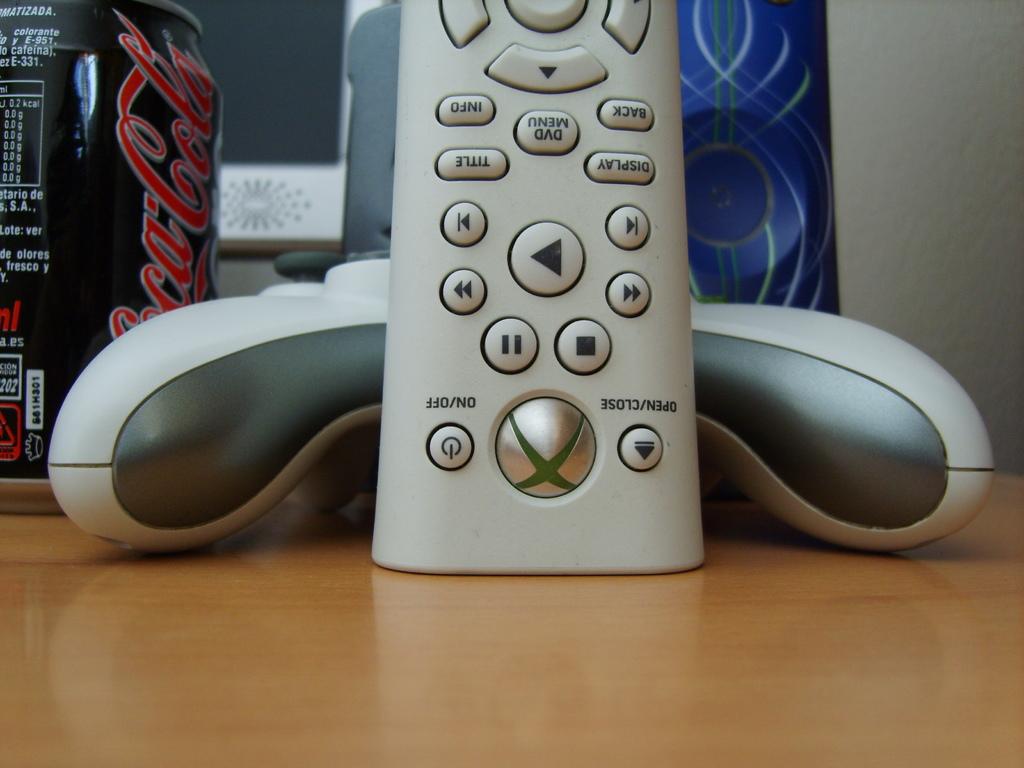What is the brand of soda?
Give a very brief answer. Coca cola. What games brand is this controller?
Provide a succinct answer. Xbox. 